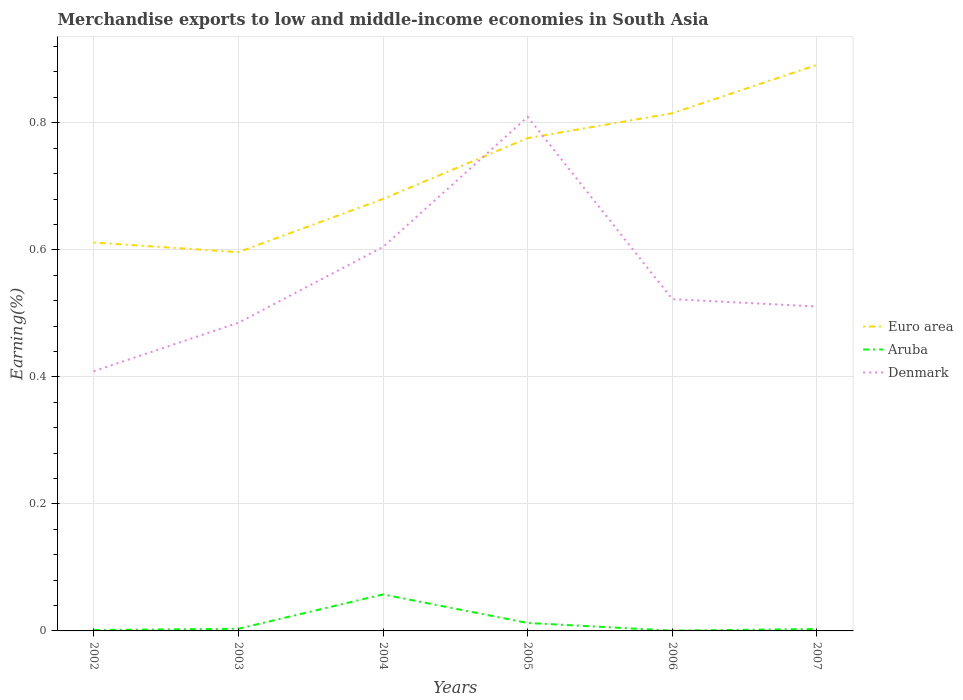Does the line corresponding to Denmark intersect with the line corresponding to Aruba?
Your answer should be compact. No. Is the number of lines equal to the number of legend labels?
Offer a very short reply. Yes. Across all years, what is the maximum percentage of amount earned from merchandise exports in Denmark?
Make the answer very short. 0.41. In which year was the percentage of amount earned from merchandise exports in Euro area maximum?
Your response must be concise. 2003. What is the total percentage of amount earned from merchandise exports in Euro area in the graph?
Keep it short and to the point. -0.16. What is the difference between the highest and the second highest percentage of amount earned from merchandise exports in Aruba?
Offer a terse response. 0.06. What is the difference between the highest and the lowest percentage of amount earned from merchandise exports in Aruba?
Provide a succinct answer. 1. Is the percentage of amount earned from merchandise exports in Euro area strictly greater than the percentage of amount earned from merchandise exports in Aruba over the years?
Offer a terse response. No. How many lines are there?
Your answer should be very brief. 3. What is the difference between two consecutive major ticks on the Y-axis?
Your answer should be compact. 0.2. Are the values on the major ticks of Y-axis written in scientific E-notation?
Offer a terse response. No. Does the graph contain any zero values?
Your response must be concise. No. Does the graph contain grids?
Offer a terse response. Yes. Where does the legend appear in the graph?
Offer a very short reply. Center right. How many legend labels are there?
Keep it short and to the point. 3. How are the legend labels stacked?
Your response must be concise. Vertical. What is the title of the graph?
Provide a succinct answer. Merchandise exports to low and middle-income economies in South Asia. What is the label or title of the X-axis?
Your answer should be very brief. Years. What is the label or title of the Y-axis?
Provide a succinct answer. Earning(%). What is the Earning(%) in Euro area in 2002?
Give a very brief answer. 0.61. What is the Earning(%) in Aruba in 2002?
Provide a succinct answer. 0. What is the Earning(%) of Denmark in 2002?
Keep it short and to the point. 0.41. What is the Earning(%) of Euro area in 2003?
Give a very brief answer. 0.6. What is the Earning(%) of Aruba in 2003?
Give a very brief answer. 0. What is the Earning(%) in Denmark in 2003?
Give a very brief answer. 0.49. What is the Earning(%) of Euro area in 2004?
Make the answer very short. 0.68. What is the Earning(%) of Aruba in 2004?
Your response must be concise. 0.06. What is the Earning(%) in Denmark in 2004?
Offer a terse response. 0.6. What is the Earning(%) in Euro area in 2005?
Your answer should be very brief. 0.78. What is the Earning(%) in Aruba in 2005?
Make the answer very short. 0.01. What is the Earning(%) of Denmark in 2005?
Offer a very short reply. 0.81. What is the Earning(%) of Euro area in 2006?
Provide a short and direct response. 0.82. What is the Earning(%) of Aruba in 2006?
Your answer should be compact. 0. What is the Earning(%) in Denmark in 2006?
Offer a very short reply. 0.52. What is the Earning(%) in Euro area in 2007?
Offer a very short reply. 0.89. What is the Earning(%) in Aruba in 2007?
Make the answer very short. 0. What is the Earning(%) of Denmark in 2007?
Keep it short and to the point. 0.51. Across all years, what is the maximum Earning(%) of Euro area?
Offer a very short reply. 0.89. Across all years, what is the maximum Earning(%) in Aruba?
Keep it short and to the point. 0.06. Across all years, what is the maximum Earning(%) in Denmark?
Offer a very short reply. 0.81. Across all years, what is the minimum Earning(%) of Euro area?
Provide a short and direct response. 0.6. Across all years, what is the minimum Earning(%) in Aruba?
Your response must be concise. 0. Across all years, what is the minimum Earning(%) in Denmark?
Offer a terse response. 0.41. What is the total Earning(%) in Euro area in the graph?
Make the answer very short. 4.37. What is the total Earning(%) in Aruba in the graph?
Your answer should be very brief. 0.08. What is the total Earning(%) of Denmark in the graph?
Provide a succinct answer. 3.34. What is the difference between the Earning(%) of Euro area in 2002 and that in 2003?
Your answer should be compact. 0.02. What is the difference between the Earning(%) in Aruba in 2002 and that in 2003?
Keep it short and to the point. -0. What is the difference between the Earning(%) in Denmark in 2002 and that in 2003?
Offer a terse response. -0.08. What is the difference between the Earning(%) of Euro area in 2002 and that in 2004?
Your answer should be very brief. -0.07. What is the difference between the Earning(%) in Aruba in 2002 and that in 2004?
Make the answer very short. -0.06. What is the difference between the Earning(%) in Denmark in 2002 and that in 2004?
Your answer should be very brief. -0.2. What is the difference between the Earning(%) in Euro area in 2002 and that in 2005?
Your answer should be very brief. -0.16. What is the difference between the Earning(%) of Aruba in 2002 and that in 2005?
Offer a very short reply. -0.01. What is the difference between the Earning(%) of Denmark in 2002 and that in 2005?
Your answer should be very brief. -0.4. What is the difference between the Earning(%) in Euro area in 2002 and that in 2006?
Your response must be concise. -0.2. What is the difference between the Earning(%) in Denmark in 2002 and that in 2006?
Give a very brief answer. -0.11. What is the difference between the Earning(%) in Euro area in 2002 and that in 2007?
Your response must be concise. -0.28. What is the difference between the Earning(%) of Aruba in 2002 and that in 2007?
Make the answer very short. -0. What is the difference between the Earning(%) of Denmark in 2002 and that in 2007?
Offer a very short reply. -0.1. What is the difference between the Earning(%) of Euro area in 2003 and that in 2004?
Keep it short and to the point. -0.08. What is the difference between the Earning(%) of Aruba in 2003 and that in 2004?
Offer a terse response. -0.05. What is the difference between the Earning(%) in Denmark in 2003 and that in 2004?
Your response must be concise. -0.12. What is the difference between the Earning(%) of Euro area in 2003 and that in 2005?
Make the answer very short. -0.18. What is the difference between the Earning(%) of Aruba in 2003 and that in 2005?
Keep it short and to the point. -0.01. What is the difference between the Earning(%) in Denmark in 2003 and that in 2005?
Your answer should be very brief. -0.32. What is the difference between the Earning(%) in Euro area in 2003 and that in 2006?
Give a very brief answer. -0.22. What is the difference between the Earning(%) of Aruba in 2003 and that in 2006?
Your response must be concise. 0. What is the difference between the Earning(%) of Denmark in 2003 and that in 2006?
Provide a short and direct response. -0.04. What is the difference between the Earning(%) of Euro area in 2003 and that in 2007?
Ensure brevity in your answer.  -0.29. What is the difference between the Earning(%) in Denmark in 2003 and that in 2007?
Your response must be concise. -0.03. What is the difference between the Earning(%) of Euro area in 2004 and that in 2005?
Make the answer very short. -0.1. What is the difference between the Earning(%) of Aruba in 2004 and that in 2005?
Keep it short and to the point. 0.04. What is the difference between the Earning(%) in Denmark in 2004 and that in 2005?
Keep it short and to the point. -0.2. What is the difference between the Earning(%) of Euro area in 2004 and that in 2006?
Your answer should be very brief. -0.13. What is the difference between the Earning(%) in Aruba in 2004 and that in 2006?
Offer a terse response. 0.06. What is the difference between the Earning(%) of Denmark in 2004 and that in 2006?
Your answer should be very brief. 0.08. What is the difference between the Earning(%) in Euro area in 2004 and that in 2007?
Your answer should be compact. -0.21. What is the difference between the Earning(%) of Aruba in 2004 and that in 2007?
Give a very brief answer. 0.05. What is the difference between the Earning(%) of Denmark in 2004 and that in 2007?
Give a very brief answer. 0.09. What is the difference between the Earning(%) in Euro area in 2005 and that in 2006?
Your answer should be very brief. -0.04. What is the difference between the Earning(%) in Aruba in 2005 and that in 2006?
Your answer should be very brief. 0.01. What is the difference between the Earning(%) of Denmark in 2005 and that in 2006?
Give a very brief answer. 0.29. What is the difference between the Earning(%) of Euro area in 2005 and that in 2007?
Provide a short and direct response. -0.12. What is the difference between the Earning(%) of Aruba in 2005 and that in 2007?
Make the answer very short. 0.01. What is the difference between the Earning(%) of Denmark in 2005 and that in 2007?
Make the answer very short. 0.3. What is the difference between the Earning(%) in Euro area in 2006 and that in 2007?
Provide a succinct answer. -0.08. What is the difference between the Earning(%) of Aruba in 2006 and that in 2007?
Your response must be concise. -0. What is the difference between the Earning(%) in Denmark in 2006 and that in 2007?
Your answer should be very brief. 0.01. What is the difference between the Earning(%) of Euro area in 2002 and the Earning(%) of Aruba in 2003?
Make the answer very short. 0.61. What is the difference between the Earning(%) in Euro area in 2002 and the Earning(%) in Denmark in 2003?
Offer a terse response. 0.13. What is the difference between the Earning(%) of Aruba in 2002 and the Earning(%) of Denmark in 2003?
Ensure brevity in your answer.  -0.48. What is the difference between the Earning(%) in Euro area in 2002 and the Earning(%) in Aruba in 2004?
Ensure brevity in your answer.  0.55. What is the difference between the Earning(%) of Euro area in 2002 and the Earning(%) of Denmark in 2004?
Offer a terse response. 0.01. What is the difference between the Earning(%) of Aruba in 2002 and the Earning(%) of Denmark in 2004?
Give a very brief answer. -0.6. What is the difference between the Earning(%) of Euro area in 2002 and the Earning(%) of Aruba in 2005?
Your answer should be compact. 0.6. What is the difference between the Earning(%) in Euro area in 2002 and the Earning(%) in Denmark in 2005?
Ensure brevity in your answer.  -0.2. What is the difference between the Earning(%) of Aruba in 2002 and the Earning(%) of Denmark in 2005?
Give a very brief answer. -0.81. What is the difference between the Earning(%) in Euro area in 2002 and the Earning(%) in Aruba in 2006?
Ensure brevity in your answer.  0.61. What is the difference between the Earning(%) of Euro area in 2002 and the Earning(%) of Denmark in 2006?
Ensure brevity in your answer.  0.09. What is the difference between the Earning(%) in Aruba in 2002 and the Earning(%) in Denmark in 2006?
Provide a succinct answer. -0.52. What is the difference between the Earning(%) in Euro area in 2002 and the Earning(%) in Aruba in 2007?
Provide a short and direct response. 0.61. What is the difference between the Earning(%) in Euro area in 2002 and the Earning(%) in Denmark in 2007?
Give a very brief answer. 0.1. What is the difference between the Earning(%) in Aruba in 2002 and the Earning(%) in Denmark in 2007?
Your response must be concise. -0.51. What is the difference between the Earning(%) in Euro area in 2003 and the Earning(%) in Aruba in 2004?
Provide a succinct answer. 0.54. What is the difference between the Earning(%) of Euro area in 2003 and the Earning(%) of Denmark in 2004?
Your response must be concise. -0.01. What is the difference between the Earning(%) in Aruba in 2003 and the Earning(%) in Denmark in 2004?
Provide a succinct answer. -0.6. What is the difference between the Earning(%) in Euro area in 2003 and the Earning(%) in Aruba in 2005?
Keep it short and to the point. 0.58. What is the difference between the Earning(%) of Euro area in 2003 and the Earning(%) of Denmark in 2005?
Give a very brief answer. -0.21. What is the difference between the Earning(%) in Aruba in 2003 and the Earning(%) in Denmark in 2005?
Provide a short and direct response. -0.81. What is the difference between the Earning(%) of Euro area in 2003 and the Earning(%) of Aruba in 2006?
Keep it short and to the point. 0.6. What is the difference between the Earning(%) of Euro area in 2003 and the Earning(%) of Denmark in 2006?
Keep it short and to the point. 0.07. What is the difference between the Earning(%) in Aruba in 2003 and the Earning(%) in Denmark in 2006?
Provide a short and direct response. -0.52. What is the difference between the Earning(%) in Euro area in 2003 and the Earning(%) in Aruba in 2007?
Keep it short and to the point. 0.59. What is the difference between the Earning(%) of Euro area in 2003 and the Earning(%) of Denmark in 2007?
Provide a short and direct response. 0.09. What is the difference between the Earning(%) of Aruba in 2003 and the Earning(%) of Denmark in 2007?
Offer a very short reply. -0.51. What is the difference between the Earning(%) of Euro area in 2004 and the Earning(%) of Aruba in 2005?
Your answer should be very brief. 0.67. What is the difference between the Earning(%) in Euro area in 2004 and the Earning(%) in Denmark in 2005?
Offer a terse response. -0.13. What is the difference between the Earning(%) in Aruba in 2004 and the Earning(%) in Denmark in 2005?
Your answer should be compact. -0.75. What is the difference between the Earning(%) in Euro area in 2004 and the Earning(%) in Aruba in 2006?
Your answer should be very brief. 0.68. What is the difference between the Earning(%) in Euro area in 2004 and the Earning(%) in Denmark in 2006?
Offer a very short reply. 0.16. What is the difference between the Earning(%) in Aruba in 2004 and the Earning(%) in Denmark in 2006?
Ensure brevity in your answer.  -0.46. What is the difference between the Earning(%) in Euro area in 2004 and the Earning(%) in Aruba in 2007?
Your answer should be very brief. 0.68. What is the difference between the Earning(%) in Euro area in 2004 and the Earning(%) in Denmark in 2007?
Offer a terse response. 0.17. What is the difference between the Earning(%) of Aruba in 2004 and the Earning(%) of Denmark in 2007?
Provide a succinct answer. -0.45. What is the difference between the Earning(%) in Euro area in 2005 and the Earning(%) in Aruba in 2006?
Keep it short and to the point. 0.78. What is the difference between the Earning(%) of Euro area in 2005 and the Earning(%) of Denmark in 2006?
Offer a very short reply. 0.25. What is the difference between the Earning(%) in Aruba in 2005 and the Earning(%) in Denmark in 2006?
Your response must be concise. -0.51. What is the difference between the Earning(%) of Euro area in 2005 and the Earning(%) of Aruba in 2007?
Provide a succinct answer. 0.77. What is the difference between the Earning(%) in Euro area in 2005 and the Earning(%) in Denmark in 2007?
Provide a succinct answer. 0.27. What is the difference between the Earning(%) of Aruba in 2005 and the Earning(%) of Denmark in 2007?
Your answer should be compact. -0.5. What is the difference between the Earning(%) in Euro area in 2006 and the Earning(%) in Aruba in 2007?
Give a very brief answer. 0.81. What is the difference between the Earning(%) of Euro area in 2006 and the Earning(%) of Denmark in 2007?
Your answer should be very brief. 0.3. What is the difference between the Earning(%) of Aruba in 2006 and the Earning(%) of Denmark in 2007?
Ensure brevity in your answer.  -0.51. What is the average Earning(%) of Euro area per year?
Provide a succinct answer. 0.73. What is the average Earning(%) in Aruba per year?
Offer a very short reply. 0.01. What is the average Earning(%) in Denmark per year?
Offer a very short reply. 0.56. In the year 2002, what is the difference between the Earning(%) in Euro area and Earning(%) in Aruba?
Ensure brevity in your answer.  0.61. In the year 2002, what is the difference between the Earning(%) in Euro area and Earning(%) in Denmark?
Ensure brevity in your answer.  0.2. In the year 2002, what is the difference between the Earning(%) of Aruba and Earning(%) of Denmark?
Your answer should be compact. -0.41. In the year 2003, what is the difference between the Earning(%) in Euro area and Earning(%) in Aruba?
Provide a succinct answer. 0.59. In the year 2003, what is the difference between the Earning(%) of Euro area and Earning(%) of Denmark?
Your answer should be compact. 0.11. In the year 2003, what is the difference between the Earning(%) of Aruba and Earning(%) of Denmark?
Offer a very short reply. -0.48. In the year 2004, what is the difference between the Earning(%) in Euro area and Earning(%) in Aruba?
Provide a short and direct response. 0.62. In the year 2004, what is the difference between the Earning(%) of Euro area and Earning(%) of Denmark?
Offer a terse response. 0.08. In the year 2004, what is the difference between the Earning(%) of Aruba and Earning(%) of Denmark?
Your answer should be compact. -0.55. In the year 2005, what is the difference between the Earning(%) of Euro area and Earning(%) of Aruba?
Offer a terse response. 0.76. In the year 2005, what is the difference between the Earning(%) of Euro area and Earning(%) of Denmark?
Keep it short and to the point. -0.03. In the year 2005, what is the difference between the Earning(%) of Aruba and Earning(%) of Denmark?
Your answer should be compact. -0.8. In the year 2006, what is the difference between the Earning(%) of Euro area and Earning(%) of Aruba?
Your answer should be compact. 0.81. In the year 2006, what is the difference between the Earning(%) of Euro area and Earning(%) of Denmark?
Offer a terse response. 0.29. In the year 2006, what is the difference between the Earning(%) in Aruba and Earning(%) in Denmark?
Keep it short and to the point. -0.52. In the year 2007, what is the difference between the Earning(%) of Euro area and Earning(%) of Aruba?
Keep it short and to the point. 0.89. In the year 2007, what is the difference between the Earning(%) of Euro area and Earning(%) of Denmark?
Your response must be concise. 0.38. In the year 2007, what is the difference between the Earning(%) in Aruba and Earning(%) in Denmark?
Make the answer very short. -0.51. What is the ratio of the Earning(%) in Euro area in 2002 to that in 2003?
Provide a short and direct response. 1.03. What is the ratio of the Earning(%) in Aruba in 2002 to that in 2003?
Offer a very short reply. 0.43. What is the ratio of the Earning(%) in Denmark in 2002 to that in 2003?
Ensure brevity in your answer.  0.84. What is the ratio of the Earning(%) of Euro area in 2002 to that in 2004?
Provide a succinct answer. 0.9. What is the ratio of the Earning(%) of Aruba in 2002 to that in 2004?
Give a very brief answer. 0.03. What is the ratio of the Earning(%) of Denmark in 2002 to that in 2004?
Ensure brevity in your answer.  0.68. What is the ratio of the Earning(%) in Euro area in 2002 to that in 2005?
Keep it short and to the point. 0.79. What is the ratio of the Earning(%) of Aruba in 2002 to that in 2005?
Your response must be concise. 0.12. What is the ratio of the Earning(%) of Denmark in 2002 to that in 2005?
Provide a short and direct response. 0.51. What is the ratio of the Earning(%) of Euro area in 2002 to that in 2006?
Provide a short and direct response. 0.75. What is the ratio of the Earning(%) in Aruba in 2002 to that in 2006?
Make the answer very short. 3.13. What is the ratio of the Earning(%) of Denmark in 2002 to that in 2006?
Your response must be concise. 0.78. What is the ratio of the Earning(%) of Euro area in 2002 to that in 2007?
Provide a succinct answer. 0.69. What is the ratio of the Earning(%) of Aruba in 2002 to that in 2007?
Offer a very short reply. 0.48. What is the ratio of the Earning(%) of Denmark in 2002 to that in 2007?
Provide a succinct answer. 0.8. What is the ratio of the Earning(%) of Euro area in 2003 to that in 2004?
Provide a short and direct response. 0.88. What is the ratio of the Earning(%) in Aruba in 2003 to that in 2004?
Keep it short and to the point. 0.06. What is the ratio of the Earning(%) of Denmark in 2003 to that in 2004?
Provide a short and direct response. 0.8. What is the ratio of the Earning(%) in Euro area in 2003 to that in 2005?
Provide a succinct answer. 0.77. What is the ratio of the Earning(%) of Aruba in 2003 to that in 2005?
Provide a short and direct response. 0.27. What is the ratio of the Earning(%) in Denmark in 2003 to that in 2005?
Your answer should be very brief. 0.6. What is the ratio of the Earning(%) in Euro area in 2003 to that in 2006?
Your response must be concise. 0.73. What is the ratio of the Earning(%) in Aruba in 2003 to that in 2006?
Ensure brevity in your answer.  7.23. What is the ratio of the Earning(%) of Denmark in 2003 to that in 2006?
Provide a short and direct response. 0.93. What is the ratio of the Earning(%) in Euro area in 2003 to that in 2007?
Give a very brief answer. 0.67. What is the ratio of the Earning(%) in Aruba in 2003 to that in 2007?
Make the answer very short. 1.1. What is the ratio of the Earning(%) of Denmark in 2003 to that in 2007?
Your answer should be very brief. 0.95. What is the ratio of the Earning(%) of Euro area in 2004 to that in 2005?
Offer a terse response. 0.88. What is the ratio of the Earning(%) of Aruba in 2004 to that in 2005?
Offer a very short reply. 4.58. What is the ratio of the Earning(%) of Denmark in 2004 to that in 2005?
Make the answer very short. 0.75. What is the ratio of the Earning(%) in Euro area in 2004 to that in 2006?
Your response must be concise. 0.83. What is the ratio of the Earning(%) in Aruba in 2004 to that in 2006?
Provide a short and direct response. 122.19. What is the ratio of the Earning(%) of Denmark in 2004 to that in 2006?
Offer a terse response. 1.16. What is the ratio of the Earning(%) in Euro area in 2004 to that in 2007?
Make the answer very short. 0.76. What is the ratio of the Earning(%) in Aruba in 2004 to that in 2007?
Provide a short and direct response. 18.64. What is the ratio of the Earning(%) in Denmark in 2004 to that in 2007?
Your answer should be very brief. 1.18. What is the ratio of the Earning(%) of Euro area in 2005 to that in 2006?
Offer a very short reply. 0.95. What is the ratio of the Earning(%) in Aruba in 2005 to that in 2006?
Make the answer very short. 26.66. What is the ratio of the Earning(%) in Denmark in 2005 to that in 2006?
Offer a terse response. 1.55. What is the ratio of the Earning(%) of Euro area in 2005 to that in 2007?
Keep it short and to the point. 0.87. What is the ratio of the Earning(%) in Aruba in 2005 to that in 2007?
Ensure brevity in your answer.  4.07. What is the ratio of the Earning(%) in Denmark in 2005 to that in 2007?
Ensure brevity in your answer.  1.58. What is the ratio of the Earning(%) in Euro area in 2006 to that in 2007?
Offer a very short reply. 0.91. What is the ratio of the Earning(%) of Aruba in 2006 to that in 2007?
Ensure brevity in your answer.  0.15. What is the ratio of the Earning(%) in Denmark in 2006 to that in 2007?
Your answer should be compact. 1.02. What is the difference between the highest and the second highest Earning(%) in Euro area?
Make the answer very short. 0.08. What is the difference between the highest and the second highest Earning(%) in Aruba?
Offer a terse response. 0.04. What is the difference between the highest and the second highest Earning(%) in Denmark?
Give a very brief answer. 0.2. What is the difference between the highest and the lowest Earning(%) in Euro area?
Your answer should be compact. 0.29. What is the difference between the highest and the lowest Earning(%) in Aruba?
Provide a short and direct response. 0.06. What is the difference between the highest and the lowest Earning(%) in Denmark?
Your answer should be very brief. 0.4. 